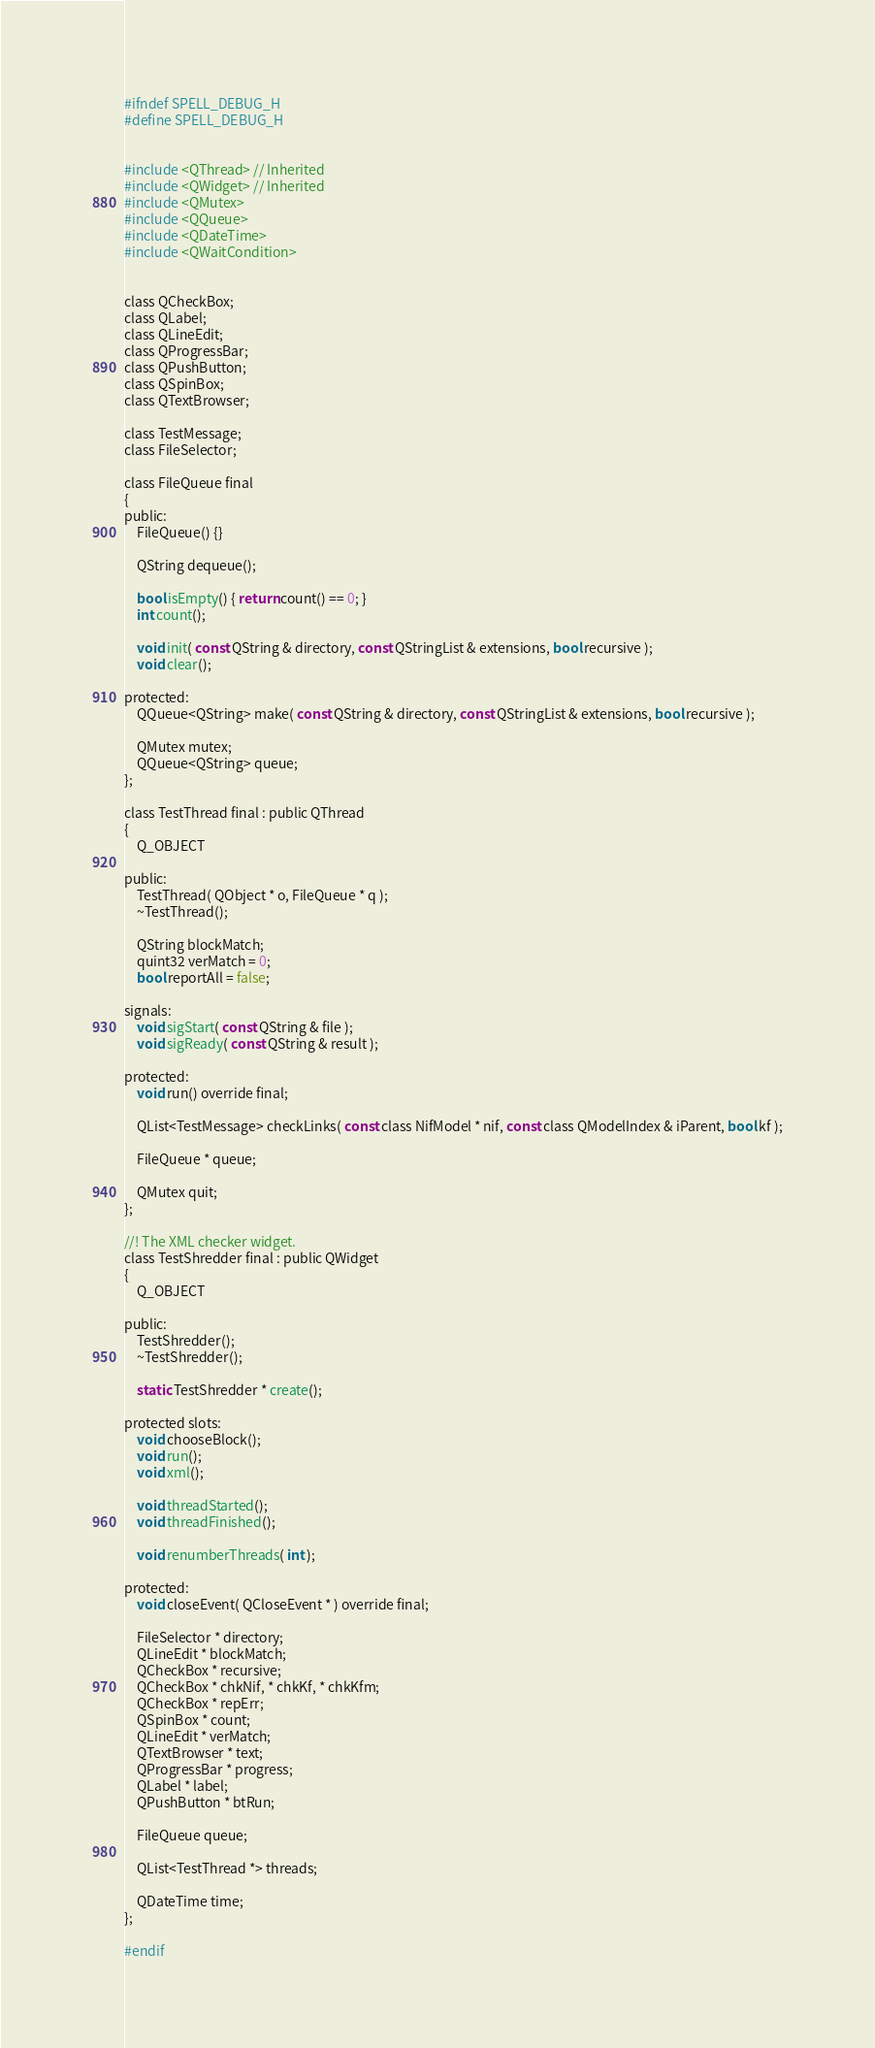Convert code to text. <code><loc_0><loc_0><loc_500><loc_500><_C_>#ifndef SPELL_DEBUG_H
#define SPELL_DEBUG_H


#include <QThread> // Inherited
#include <QWidget> // Inherited
#include <QMutex>
#include <QQueue>
#include <QDateTime>
#include <QWaitCondition>


class QCheckBox;
class QLabel;
class QLineEdit;
class QProgressBar;
class QPushButton;
class QSpinBox;
class QTextBrowser;

class TestMessage;
class FileSelector;

class FileQueue final
{
public:
	FileQueue() {}

	QString dequeue();

	bool isEmpty() { return count() == 0; }
	int count();

	void init( const QString & directory, const QStringList & extensions, bool recursive );
	void clear();

protected:
	QQueue<QString> make( const QString & directory, const QStringList & extensions, bool recursive );

	QMutex mutex;
	QQueue<QString> queue;
};

class TestThread final : public QThread
{
	Q_OBJECT

public:
	TestThread( QObject * o, FileQueue * q );
	~TestThread();

	QString blockMatch;
	quint32 verMatch = 0;
	bool reportAll = false;

signals:
	void sigStart( const QString & file );
	void sigReady( const QString & result );

protected:
	void run() override final;

	QList<TestMessage> checkLinks( const class NifModel * nif, const class QModelIndex & iParent, bool kf );

	FileQueue * queue;

	QMutex quit;
};

//! The XML checker widget.
class TestShredder final : public QWidget
{
	Q_OBJECT

public:
	TestShredder();
	~TestShredder();

	static TestShredder * create();

protected slots:
	void chooseBlock();
	void run();
	void xml();

	void threadStarted();
	void threadFinished();

	void renumberThreads( int );

protected:
	void closeEvent( QCloseEvent * ) override final;

	FileSelector * directory;
	QLineEdit * blockMatch;
	QCheckBox * recursive;
	QCheckBox * chkNif, * chkKf, * chkKfm;
	QCheckBox * repErr;
	QSpinBox * count;
	QLineEdit * verMatch;
	QTextBrowser * text;
	QProgressBar * progress;
	QLabel * label;
	QPushButton * btRun;

	FileQueue queue;

	QList<TestThread *> threads;

	QDateTime time;
};

#endif
</code> 